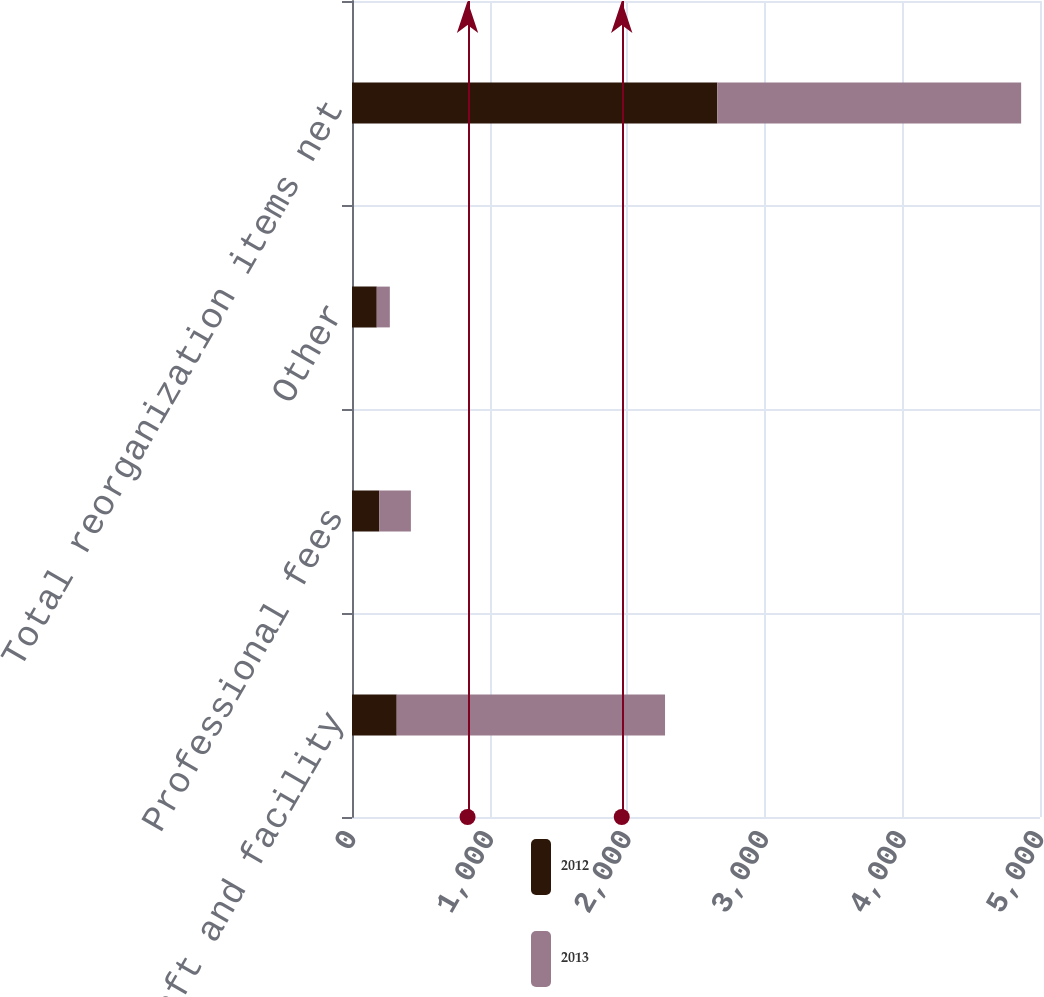Convert chart. <chart><loc_0><loc_0><loc_500><loc_500><stacked_bar_chart><ecel><fcel>Aircraft and facility<fcel>Professional fees<fcel>Other<fcel>Total reorganization items net<nl><fcel>2012<fcel>325<fcel>199<fcel>180<fcel>2655<nl><fcel>2013<fcel>1950<fcel>229<fcel>95<fcel>2208<nl></chart> 